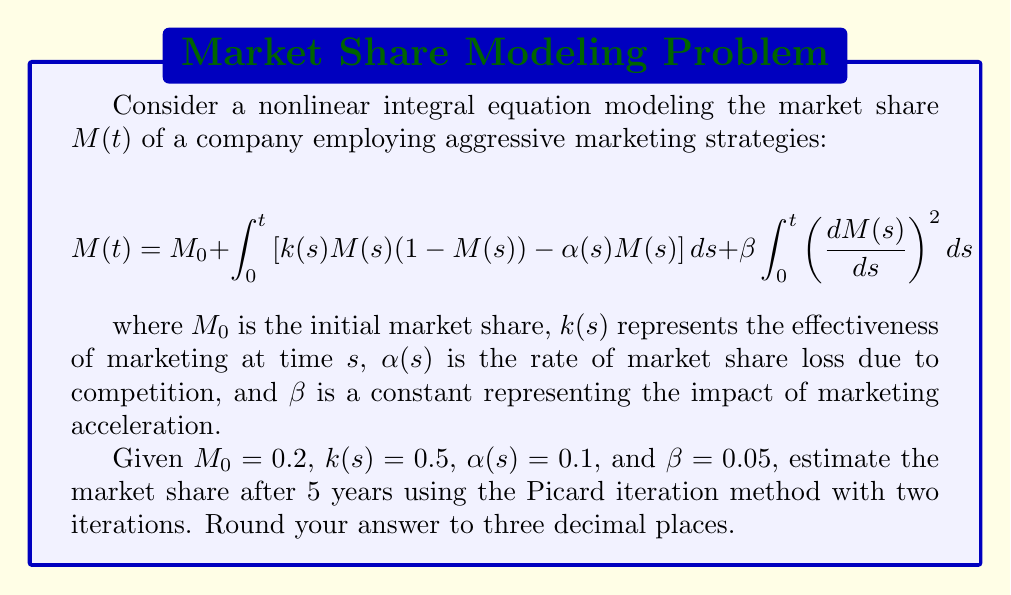Provide a solution to this math problem. To solve this problem, we'll use the Picard iteration method:

1) First iteration: $M_1(t)$
   We start with $M_0(t) = 0.2$ (the initial condition) and substitute it into the right-hand side of the equation:

   $$M_1(t) = 0.2 + \int_0^t [0.5 \cdot 0.2(1-0.2) - 0.1 \cdot 0.2] ds + 0.05 \int_0^t (0)^2 ds$$
   $$M_1(t) = 0.2 + (0.08 - 0.02)t = 0.2 + 0.06t$$

2) Second iteration: $M_2(t)$
   Now we use $M_1(t)$ in the right-hand side:

   $$M_2(t) = 0.2 + \int_0^t [0.5(0.2+0.06s)(1-(0.2+0.06s)) - 0.1(0.2+0.06s)] ds + 0.05 \int_0^t (0.06)^2 ds$$

   Simplifying the integrand:
   $$M_2(t) = 0.2 + \int_0^t [0.1 + 0.03s - 0.02 - 0.012s - 0.009s^2 - 0.02 - 0.006s] ds + 0.05 \cdot 0.0036t$$

   $$M_2(t) = 0.2 + \int_0^t [0.06 + 0.012s - 0.009s^2] ds + 0.00018t$$

   Integrating:
   $$M_2(t) = 0.2 + [0.06t + 0.006t^2 - 0.003t^3] + 0.00018t$$

   $$M_2(t) = 0.2 + 0.06018t + 0.006t^2 - 0.003t^3$$

3) Evaluating at t = 5:
   $$M_2(5) = 0.2 + 0.06018 \cdot 5 + 0.006 \cdot 25 - 0.003 \cdot 125$$
   $$M_2(5) = 0.2 + 0.3009 + 0.15 - 0.375 = 0.2759$$

Rounding to three decimal places: 0.276
Answer: 0.276 